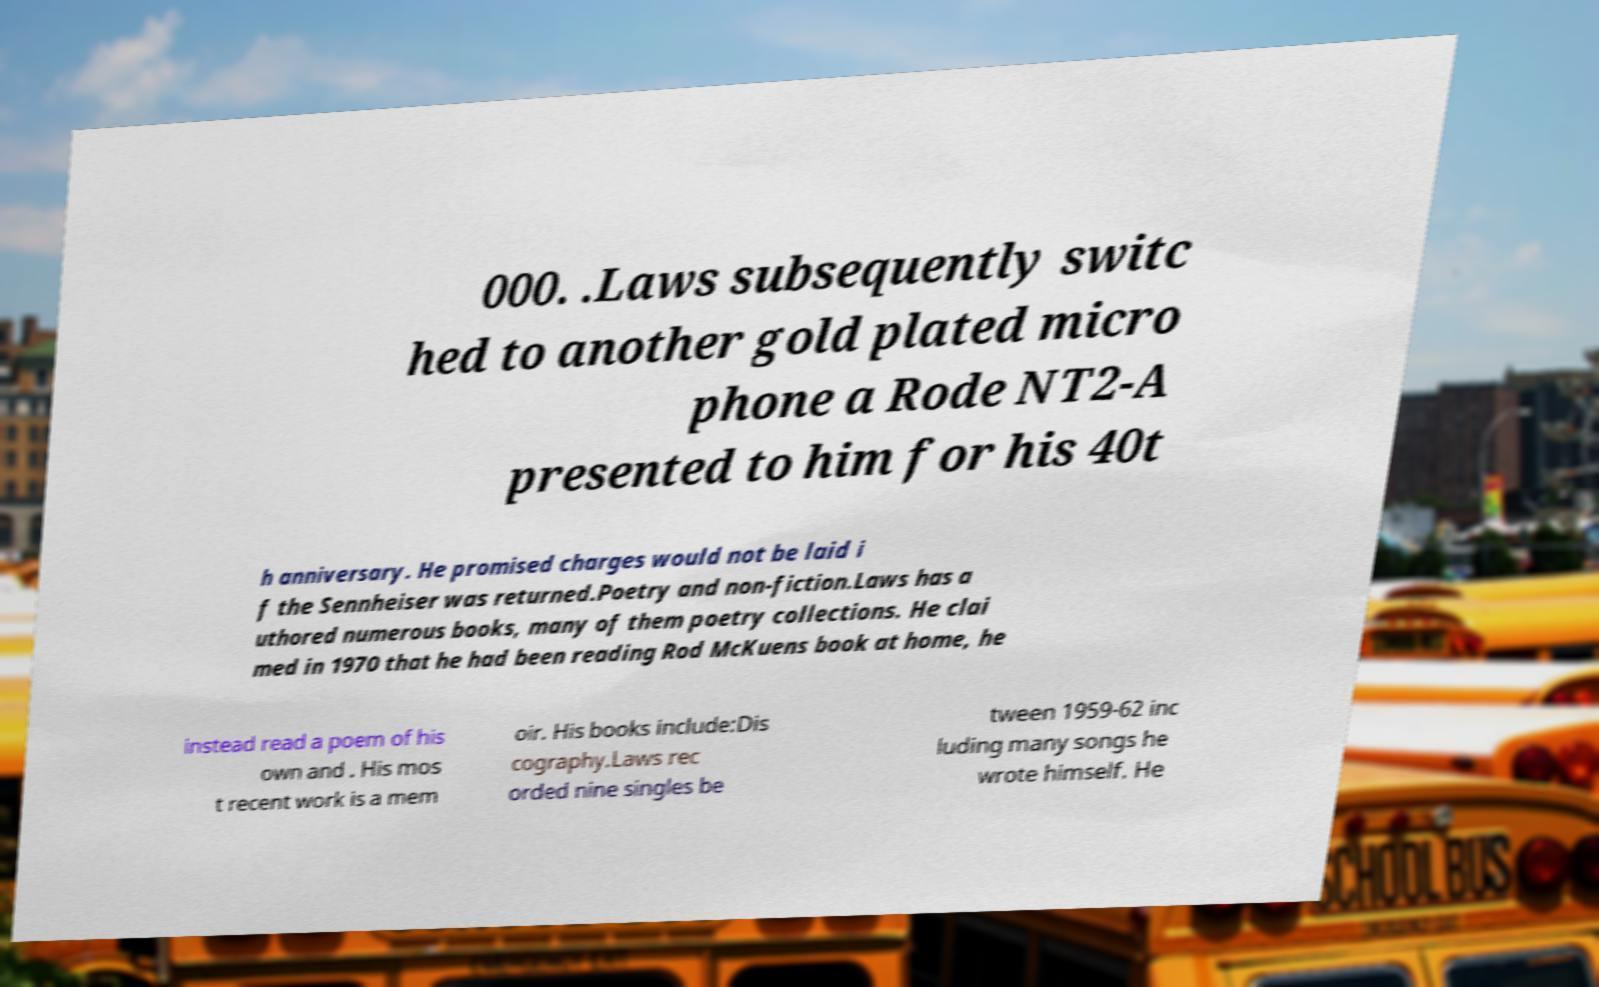Can you accurately transcribe the text from the provided image for me? 000. .Laws subsequently switc hed to another gold plated micro phone a Rode NT2-A presented to him for his 40t h anniversary. He promised charges would not be laid i f the Sennheiser was returned.Poetry and non-fiction.Laws has a uthored numerous books, many of them poetry collections. He clai med in 1970 that he had been reading Rod McKuens book at home, he instead read a poem of his own and . His mos t recent work is a mem oir. His books include:Dis cography.Laws rec orded nine singles be tween 1959-62 inc luding many songs he wrote himself. He 